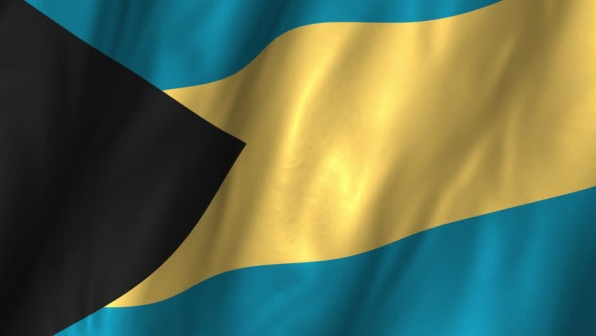Can you describe the significance of each color and shape on this flag? Absolutely! The Bahamian flag is rich with symbolism through its colors and shapes. The aquamarine stripes at the top and bottom represent the clear, crystal waters that surround the islands, a vital resource for the country. The wider gold stripe in the middle symbolizes the nation's gorgeous, sandy beaches, which are renowned worldwide. The black equilateral triangle on the left stands for the strength, resilience, and determination of the Bahamian people in their pursuit of success and unity. Each element of the flag collectively tells the story of the nation's natural beauty and the indomitable spirit of its people. 